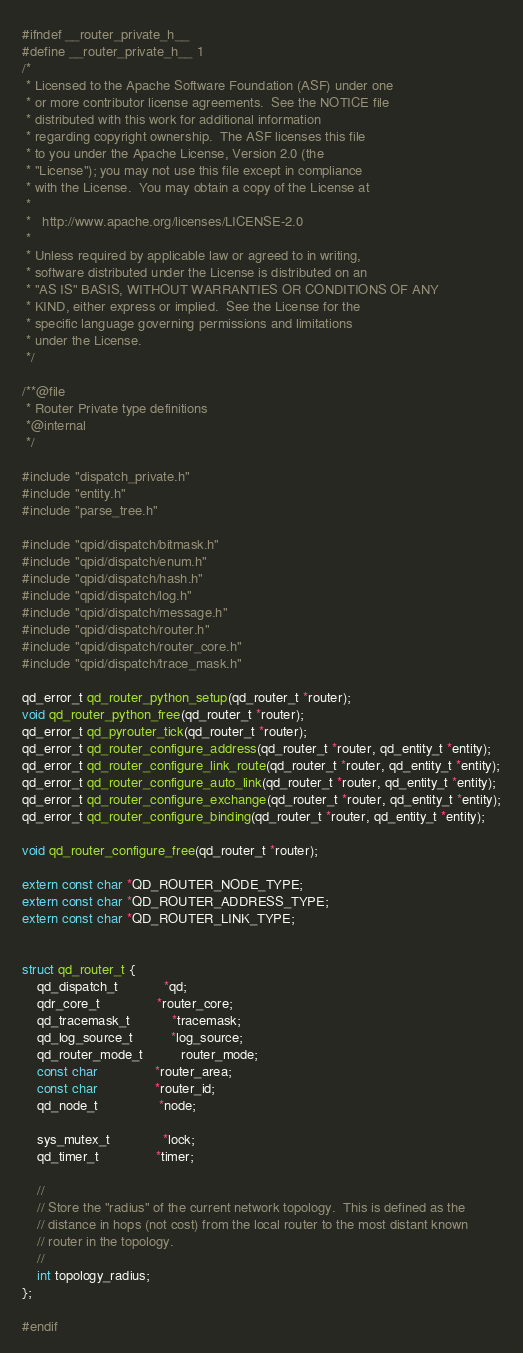<code> <loc_0><loc_0><loc_500><loc_500><_C_>#ifndef __router_private_h__
#define __router_private_h__ 1
/*
 * Licensed to the Apache Software Foundation (ASF) under one
 * or more contributor license agreements.  See the NOTICE file
 * distributed with this work for additional information
 * regarding copyright ownership.  The ASF licenses this file
 * to you under the Apache License, Version 2.0 (the
 * "License"); you may not use this file except in compliance
 * with the License.  You may obtain a copy of the License at
 *
 *   http://www.apache.org/licenses/LICENSE-2.0
 *
 * Unless required by applicable law or agreed to in writing,
 * software distributed under the License is distributed on an
 * "AS IS" BASIS, WITHOUT WARRANTIES OR CONDITIONS OF ANY
 * KIND, either express or implied.  See the License for the
 * specific language governing permissions and limitations
 * under the License.
 */

/**@file
 * Router Private type definitions
 *@internal
 */

#include "dispatch_private.h"
#include "entity.h"
#include "parse_tree.h"

#include "qpid/dispatch/bitmask.h"
#include "qpid/dispatch/enum.h"
#include "qpid/dispatch/hash.h"
#include "qpid/dispatch/log.h"
#include "qpid/dispatch/message.h"
#include "qpid/dispatch/router.h"
#include "qpid/dispatch/router_core.h"
#include "qpid/dispatch/trace_mask.h"

qd_error_t qd_router_python_setup(qd_router_t *router);
void qd_router_python_free(qd_router_t *router);
qd_error_t qd_pyrouter_tick(qd_router_t *router);
qd_error_t qd_router_configure_address(qd_router_t *router, qd_entity_t *entity);
qd_error_t qd_router_configure_link_route(qd_router_t *router, qd_entity_t *entity);
qd_error_t qd_router_configure_auto_link(qd_router_t *router, qd_entity_t *entity);
qd_error_t qd_router_configure_exchange(qd_router_t *router, qd_entity_t *entity);
qd_error_t qd_router_configure_binding(qd_router_t *router, qd_entity_t *entity);

void qd_router_configure_free(qd_router_t *router);

extern const char *QD_ROUTER_NODE_TYPE;
extern const char *QD_ROUTER_ADDRESS_TYPE;
extern const char *QD_ROUTER_LINK_TYPE;


struct qd_router_t {
    qd_dispatch_t            *qd;
    qdr_core_t               *router_core;
    qd_tracemask_t           *tracemask;
    qd_log_source_t          *log_source;
    qd_router_mode_t          router_mode;
    const char               *router_area;
    const char               *router_id;
    qd_node_t                *node;

    sys_mutex_t              *lock;
    qd_timer_t               *timer;

    //
    // Store the "radius" of the current network topology.  This is defined as the
    // distance in hops (not cost) from the local router to the most distant known
    // router in the topology.
    //
    int topology_radius;
};

#endif
</code> 